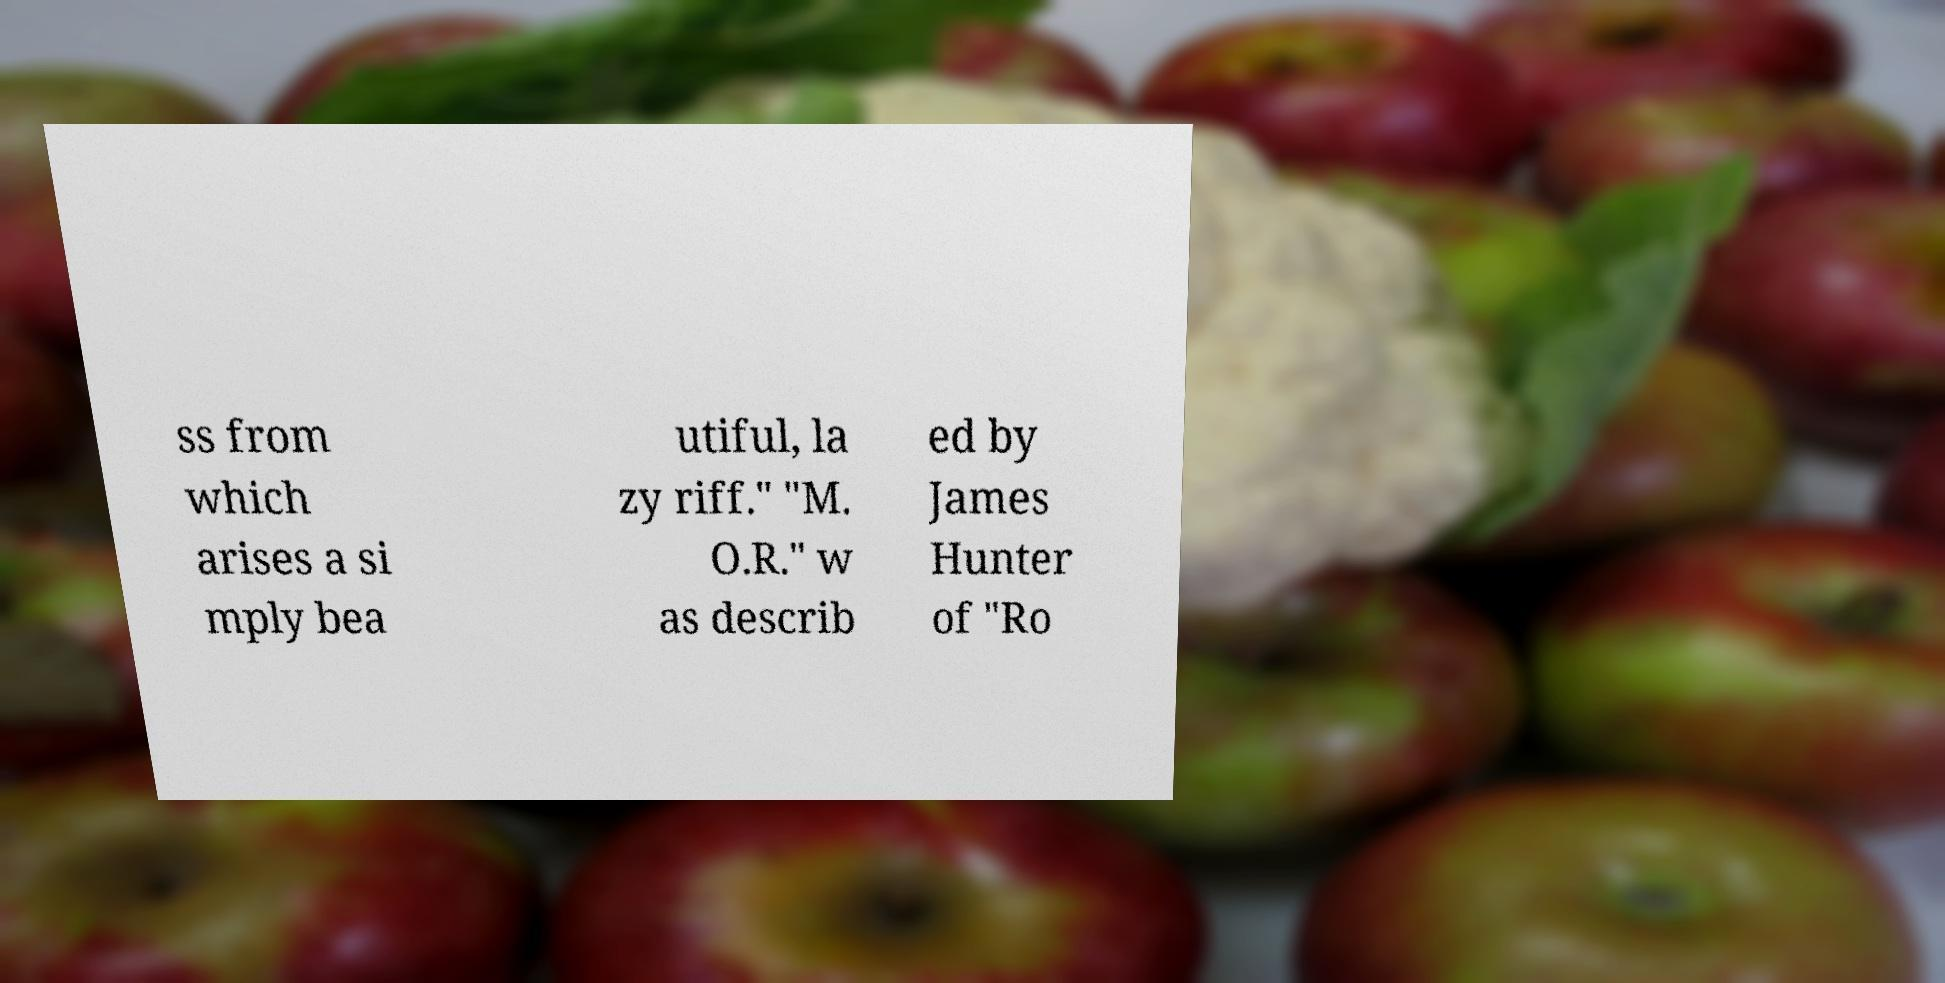Could you assist in decoding the text presented in this image and type it out clearly? ss from which arises a si mply bea utiful, la zy riff." "M. O.R." w as describ ed by James Hunter of "Ro 